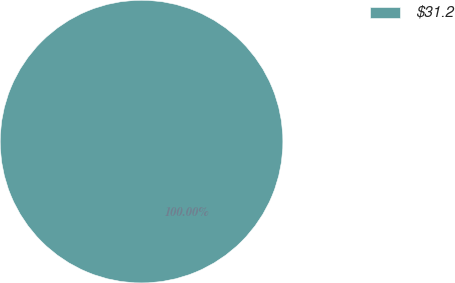Convert chart. <chart><loc_0><loc_0><loc_500><loc_500><pie_chart><fcel>$31.2<nl><fcel>100.0%<nl></chart> 